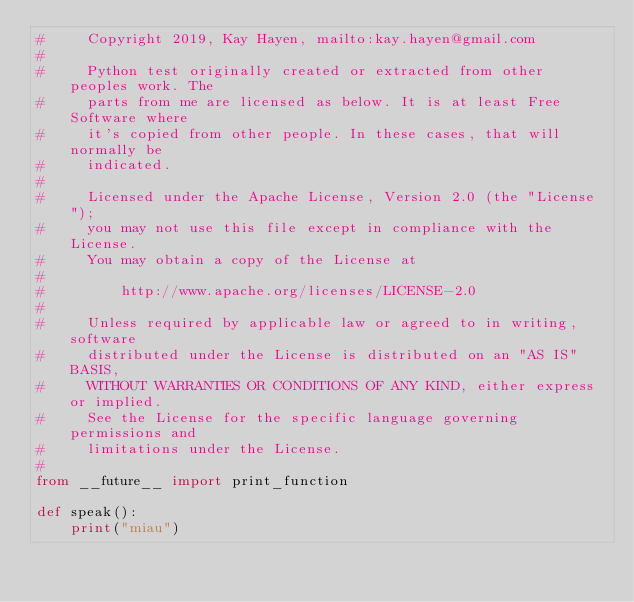<code> <loc_0><loc_0><loc_500><loc_500><_Python_>#     Copyright 2019, Kay Hayen, mailto:kay.hayen@gmail.com
#
#     Python test originally created or extracted from other peoples work. The
#     parts from me are licensed as below. It is at least Free Software where
#     it's copied from other people. In these cases, that will normally be
#     indicated.
#
#     Licensed under the Apache License, Version 2.0 (the "License");
#     you may not use this file except in compliance with the License.
#     You may obtain a copy of the License at
#
#         http://www.apache.org/licenses/LICENSE-2.0
#
#     Unless required by applicable law or agreed to in writing, software
#     distributed under the License is distributed on an "AS IS" BASIS,
#     WITHOUT WARRANTIES OR CONDITIONS OF ANY KIND, either express or implied.
#     See the License for the specific language governing permissions and
#     limitations under the License.
#
from __future__ import print_function

def speak():
    print("miau")
</code> 